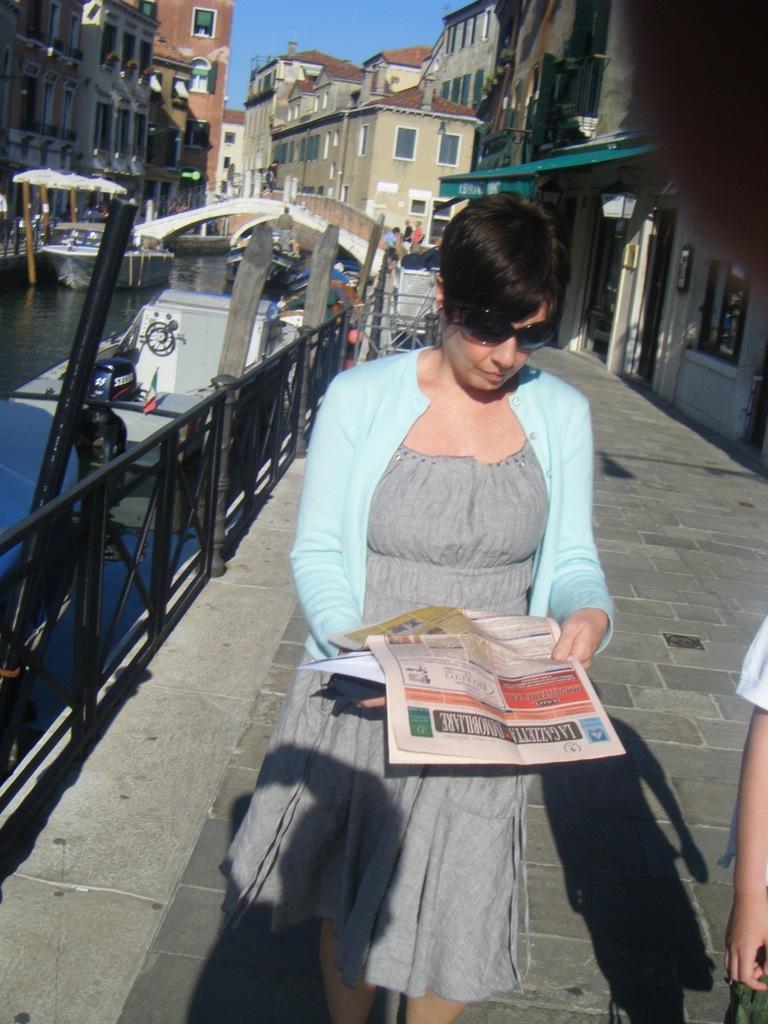How would you summarize this image in a sentence or two? In this image we can see a woman is walking on the pavement. She is holding a newspaper in her hand. On the left side of the image, we can see fence, bridge and boats on the surface of water. In the background, we can see buildings and people. At the top of the image, we can see the sky. There is a person on the right side of the image. 